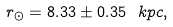<formula> <loc_0><loc_0><loc_500><loc_500>r _ { \odot } = 8 . 3 3 \pm 0 . 3 5 \ k p c ,</formula> 